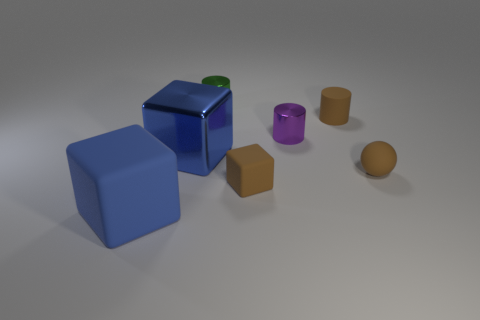Is the number of small brown matte cylinders less than the number of big cyan rubber cylinders?
Provide a short and direct response. No. Does the green thing have the same material as the tiny brown sphere?
Your response must be concise. No. There is a metal thing that is to the left of the small brown block and in front of the green metallic cylinder; what color is it?
Give a very brief answer. Blue. Are there any blue matte things that have the same size as the brown block?
Ensure brevity in your answer.  No. What is the size of the blue cube that is behind the brown object to the left of the tiny purple object?
Your answer should be compact. Large. Are there fewer blue things that are in front of the big blue metallic object than green spheres?
Keep it short and to the point. No. Does the tiny matte sphere have the same color as the big metal cube?
Keep it short and to the point. No. How big is the blue metallic block?
Give a very brief answer. Large. What number of matte cylinders are the same color as the large matte cube?
Provide a succinct answer. 0. There is a large cube that is in front of the brown thing that is in front of the brown rubber ball; are there any green objects that are in front of it?
Provide a succinct answer. No. 